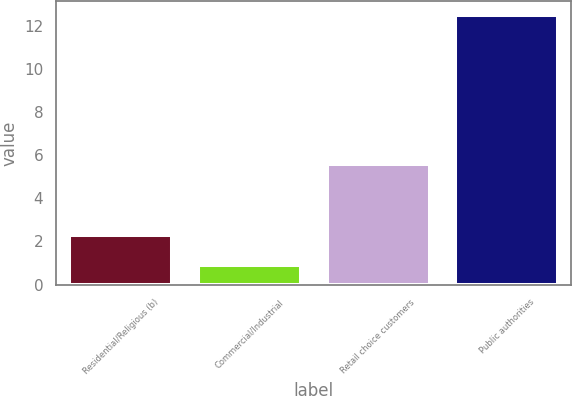<chart> <loc_0><loc_0><loc_500><loc_500><bar_chart><fcel>Residential/Religious (b)<fcel>Commercial/Industrial<fcel>Retail choice customers<fcel>Public authorities<nl><fcel>2.3<fcel>0.9<fcel>5.6<fcel>12.5<nl></chart> 